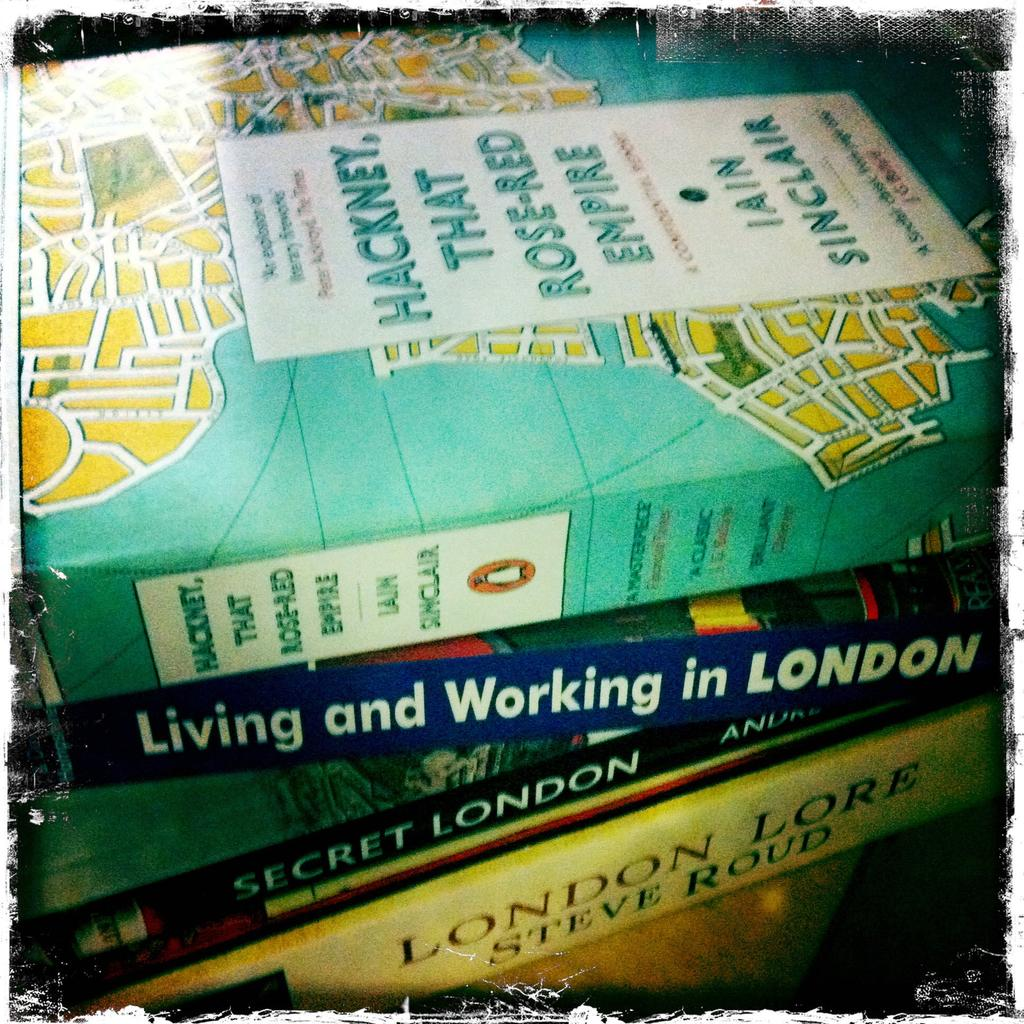<image>
Offer a succinct explanation of the picture presented. Living and Working in London is the second book in the stack from the top. 